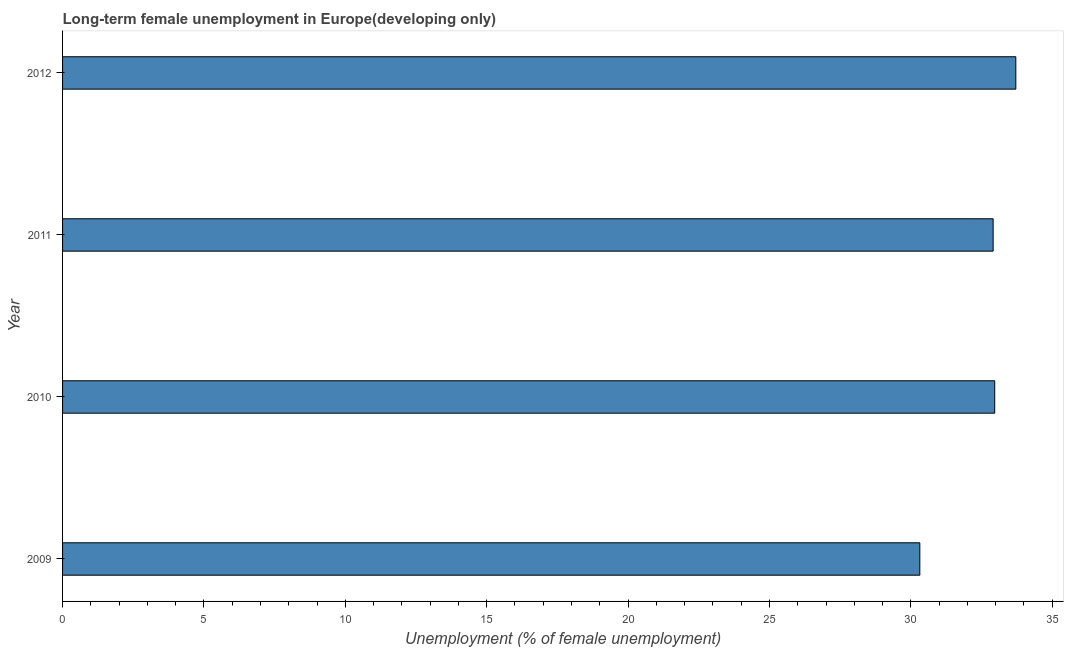Does the graph contain any zero values?
Keep it short and to the point. No. What is the title of the graph?
Keep it short and to the point. Long-term female unemployment in Europe(developing only). What is the label or title of the X-axis?
Keep it short and to the point. Unemployment (% of female unemployment). What is the long-term female unemployment in 2010?
Ensure brevity in your answer.  32.97. Across all years, what is the maximum long-term female unemployment?
Offer a terse response. 33.71. Across all years, what is the minimum long-term female unemployment?
Provide a succinct answer. 30.32. What is the sum of the long-term female unemployment?
Provide a succinct answer. 129.91. What is the difference between the long-term female unemployment in 2009 and 2012?
Your answer should be compact. -3.4. What is the average long-term female unemployment per year?
Your response must be concise. 32.48. What is the median long-term female unemployment?
Offer a terse response. 32.94. In how many years, is the long-term female unemployment greater than 17 %?
Offer a very short reply. 4. Do a majority of the years between 2009 and 2012 (inclusive) have long-term female unemployment greater than 7 %?
Keep it short and to the point. Yes. Is the long-term female unemployment in 2009 less than that in 2010?
Offer a very short reply. Yes. Is the difference between the long-term female unemployment in 2011 and 2012 greater than the difference between any two years?
Your answer should be very brief. No. What is the difference between the highest and the second highest long-term female unemployment?
Ensure brevity in your answer.  0.75. How many years are there in the graph?
Your answer should be very brief. 4. What is the difference between two consecutive major ticks on the X-axis?
Provide a short and direct response. 5. Are the values on the major ticks of X-axis written in scientific E-notation?
Provide a short and direct response. No. What is the Unemployment (% of female unemployment) in 2009?
Your response must be concise. 30.32. What is the Unemployment (% of female unemployment) of 2010?
Provide a short and direct response. 32.97. What is the Unemployment (% of female unemployment) in 2011?
Offer a very short reply. 32.91. What is the Unemployment (% of female unemployment) in 2012?
Offer a very short reply. 33.71. What is the difference between the Unemployment (% of female unemployment) in 2009 and 2010?
Your response must be concise. -2.65. What is the difference between the Unemployment (% of female unemployment) in 2009 and 2011?
Provide a short and direct response. -2.59. What is the difference between the Unemployment (% of female unemployment) in 2009 and 2012?
Keep it short and to the point. -3.4. What is the difference between the Unemployment (% of female unemployment) in 2010 and 2011?
Keep it short and to the point. 0.06. What is the difference between the Unemployment (% of female unemployment) in 2010 and 2012?
Keep it short and to the point. -0.75. What is the difference between the Unemployment (% of female unemployment) in 2011 and 2012?
Provide a short and direct response. -0.8. What is the ratio of the Unemployment (% of female unemployment) in 2009 to that in 2010?
Keep it short and to the point. 0.92. What is the ratio of the Unemployment (% of female unemployment) in 2009 to that in 2011?
Your response must be concise. 0.92. What is the ratio of the Unemployment (% of female unemployment) in 2009 to that in 2012?
Keep it short and to the point. 0.9. What is the ratio of the Unemployment (% of female unemployment) in 2010 to that in 2012?
Provide a short and direct response. 0.98. What is the ratio of the Unemployment (% of female unemployment) in 2011 to that in 2012?
Your response must be concise. 0.98. 